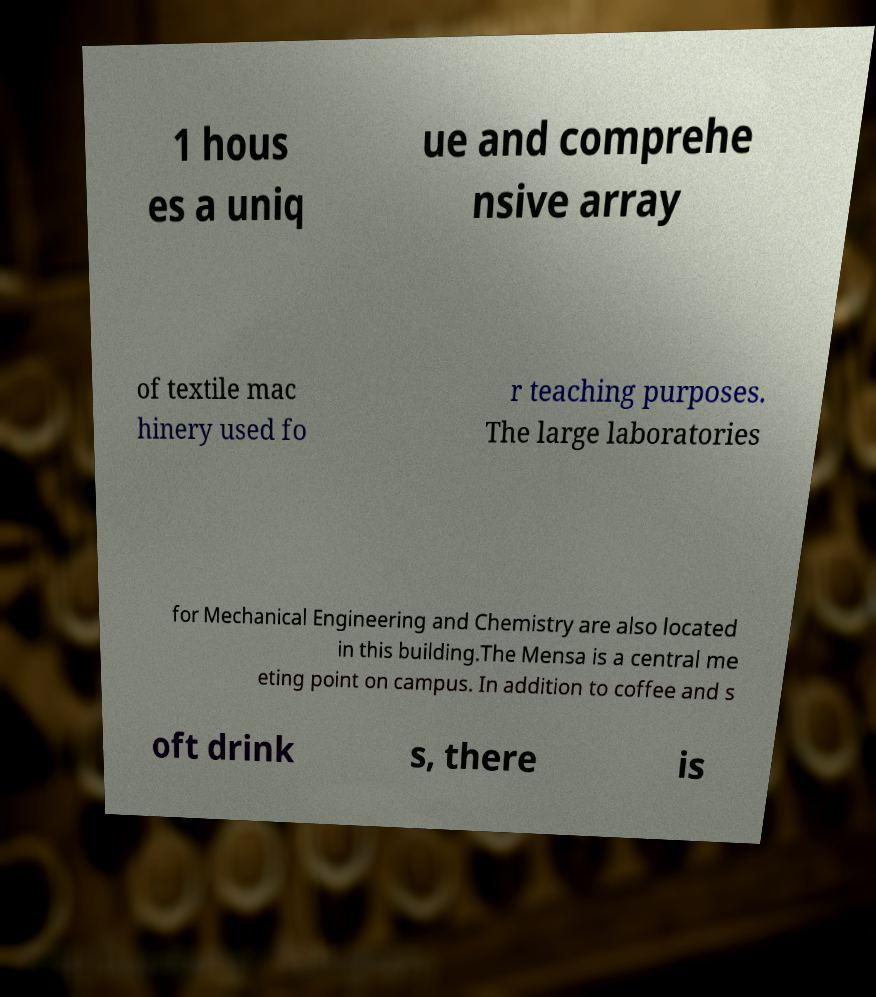Please identify and transcribe the text found in this image. 1 hous es a uniq ue and comprehe nsive array of textile mac hinery used fo r teaching purposes. The large laboratories for Mechanical Engineering and Chemistry are also located in this building.The Mensa is a central me eting point on campus. In addition to coffee and s oft drink s, there is 